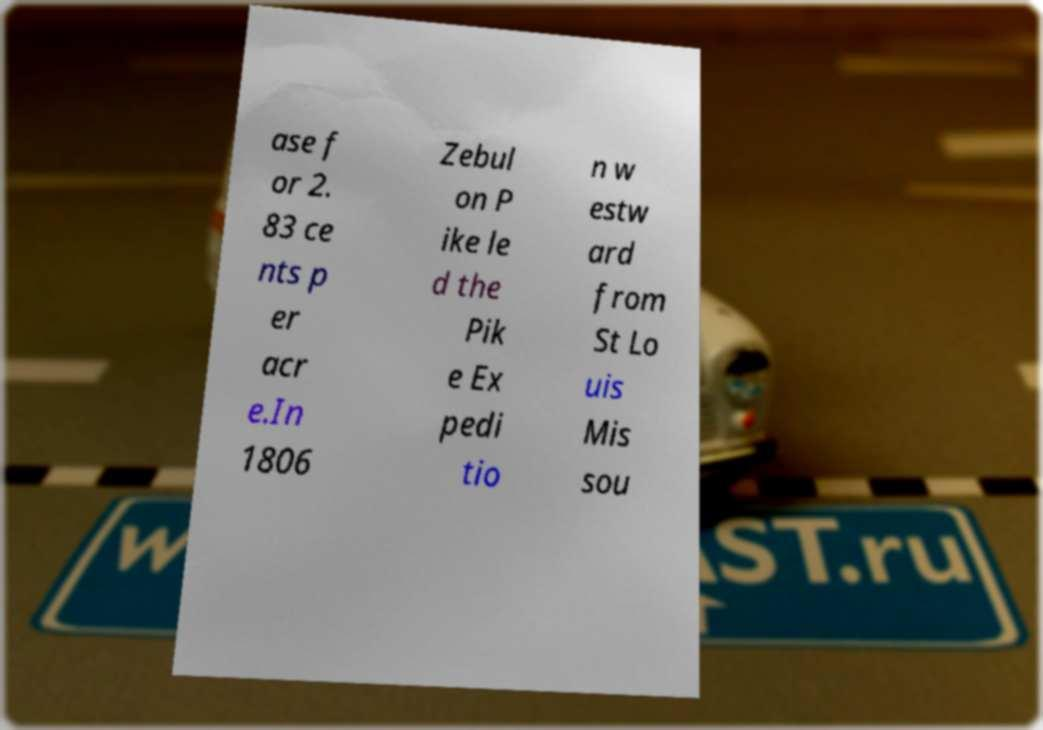Please read and relay the text visible in this image. What does it say? ase f or 2. 83 ce nts p er acr e.In 1806 Zebul on P ike le d the Pik e Ex pedi tio n w estw ard from St Lo uis Mis sou 